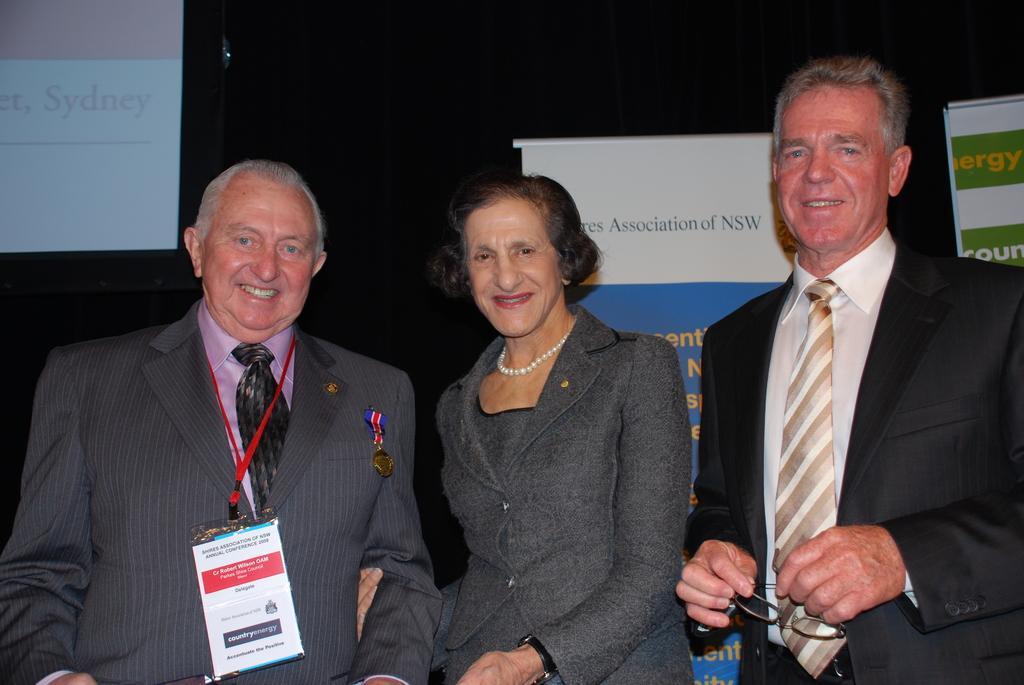Please provide a concise description of this image. In this image there are two men and a woman standing, the man is holding a spectacle, there are boards behind the persons, there is text on the boards, there is a screen towards the left of the image, there is text on the screen, the background of the image is dark. 